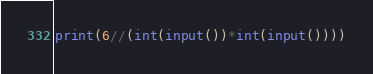Convert code to text. <code><loc_0><loc_0><loc_500><loc_500><_Python_>print(6//(int(input())*int(input())))</code> 